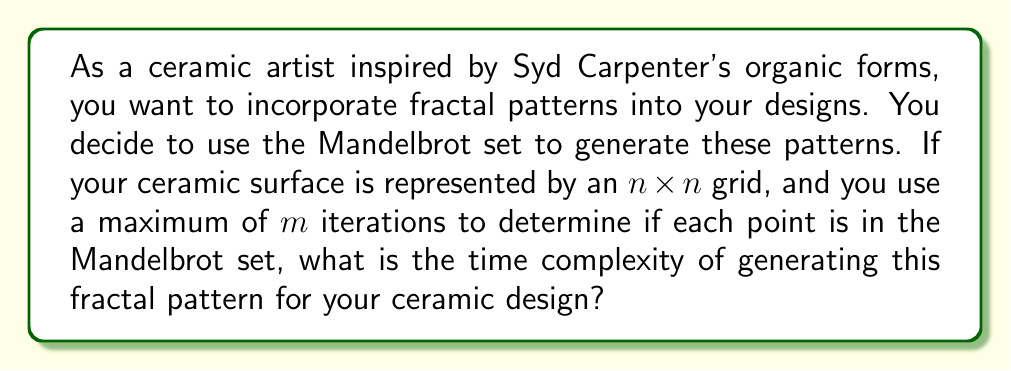Solve this math problem. To analyze the time complexity of generating a Mandelbrot set fractal pattern for an $n \times n$ grid, we need to consider the following steps:

1. We iterate through each point in the $n \times n$ grid. This requires $n^2$ iterations.

2. For each point, we perform the Mandelbrot set calculation:
   $z_{n+1} = z_n^2 + c$
   where $z_0 = 0$ and $c$ is the current point in the complex plane.

3. We repeat this calculation up to $m$ times for each point, or until $|z| > 2$ (which indicates the point is not in the set).

4. In the worst case, we perform $m$ iterations for every point.

Therefore, the total number of operations is:

$$ n^2 \cdot m $$

Each iteration involves a few basic arithmetic operations (addition, multiplication, comparison), which are considered constant time.

Thus, the time complexity of generating the Mandelbrot set fractal pattern for an $n \times n$ grid with a maximum of $m$ iterations is:

$$ O(n^2m) $$

This complexity shows that the algorithm's running time grows quadratically with the size of the grid and linearly with the maximum number of iterations.
Answer: $O(n^2m)$ 